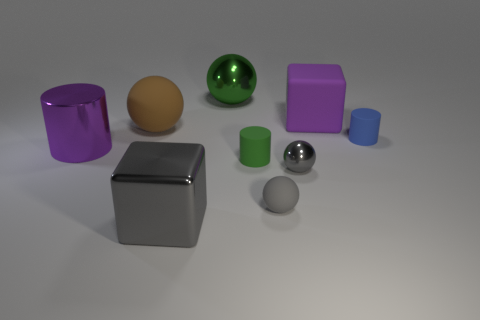Subtract all gray spheres. How many were subtracted if there are1gray spheres left? 1 Subtract 1 balls. How many balls are left? 3 Add 1 green cylinders. How many objects exist? 10 Subtract all cylinders. How many objects are left? 6 Add 7 small cyan rubber objects. How many small cyan rubber objects exist? 7 Subtract 0 yellow cubes. How many objects are left? 9 Subtract all red rubber things. Subtract all large metal spheres. How many objects are left? 8 Add 6 big metallic spheres. How many big metallic spheres are left? 7 